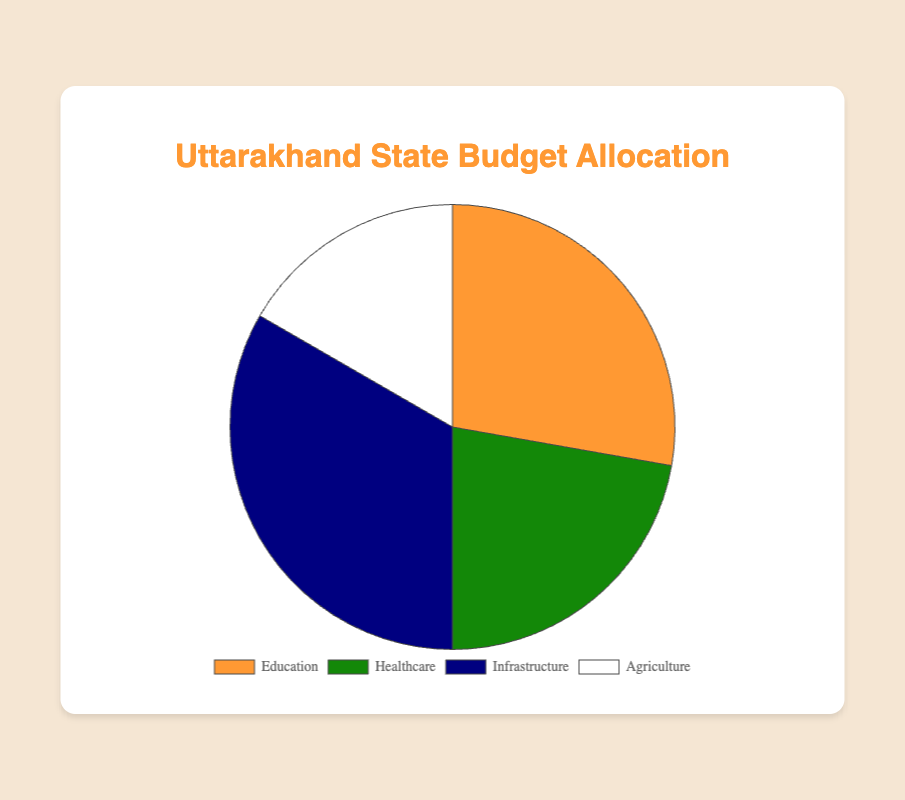What's the total percentage allocated to Healthcare and Infrastructure sectors? To find the total percentage allocated to Healthcare and Infrastructure, sum up the individual allocations: 20% (Healthcare) + 30% (Infrastructure) = 50%.
Answer: 50% What is the difference in budget allocation between Education and Agriculture? Subtract the percentage for Agriculture from the percentage for Education: 25% (Education) - 15% (Agriculture) = 10%.
Answer: 10% Which sector receives the highest percentage of budget allocation? Look at the allocations and identify the highest value. Infrastructure has the highest percentage at 30%.
Answer: Infrastructure What is the combined budget allocation for sectors with less than 20% allocation? Combine the percentages for Agriculture and Tourism since they are both less than 20%: 15% (Agriculture) + 10% (Tourism) = 25%.
Answer: 25% Is the allocation for Education greater than the combined allocation for Agriculture and Healthcare? First, find the combined allocation for Agriculture and Healthcare: 15% (Agriculture) + 20% (Healthcare) = 35%. Then, compare it with Education's 25%. Since 25% is less than 35%, the answer is no.
Answer: No Which sector receives a 10% budget allocation? Look for the sector with a 10% allocation. Tourism is allocated 10%.
Answer: Tourism How much more is allocated to Infrastructure than to Tourism? Subtract the percentage for Tourism from the percentage for Infrastructure: 30% (Infrastructure) - 10% (Tourism) = 20%.
Answer: 20% If the state decides to redistribute 5% from Infrastructure to Agriculture, what will be the new allocation for Agriculture? Add 5% to the current allocation for Agriculture: 15% + 5% = 20%.
Answer: 20% What percentage of the budget is allocated to Education and Tourism combined? Add the percentages for Education and Tourism: 25% (Education) + 10% (Tourism) = 35%.
Answer: 35% If the total state budget is ₹100 crore, how much money is allocated to Healthcare? Calculate 20% of ₹100 crore: (20/100) * 100 = ₹20 crore.
Answer: ₹20 crore 